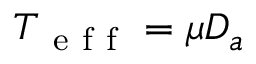Convert formula to latex. <formula><loc_0><loc_0><loc_500><loc_500>T _ { e f f } = \mu D _ { a }</formula> 